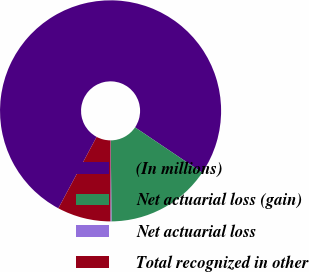Convert chart. <chart><loc_0><loc_0><loc_500><loc_500><pie_chart><fcel>(In millions)<fcel>Net actuarial loss (gain)<fcel>Net actuarial loss<fcel>Total recognized in other<nl><fcel>76.61%<fcel>15.44%<fcel>0.15%<fcel>7.8%<nl></chart> 